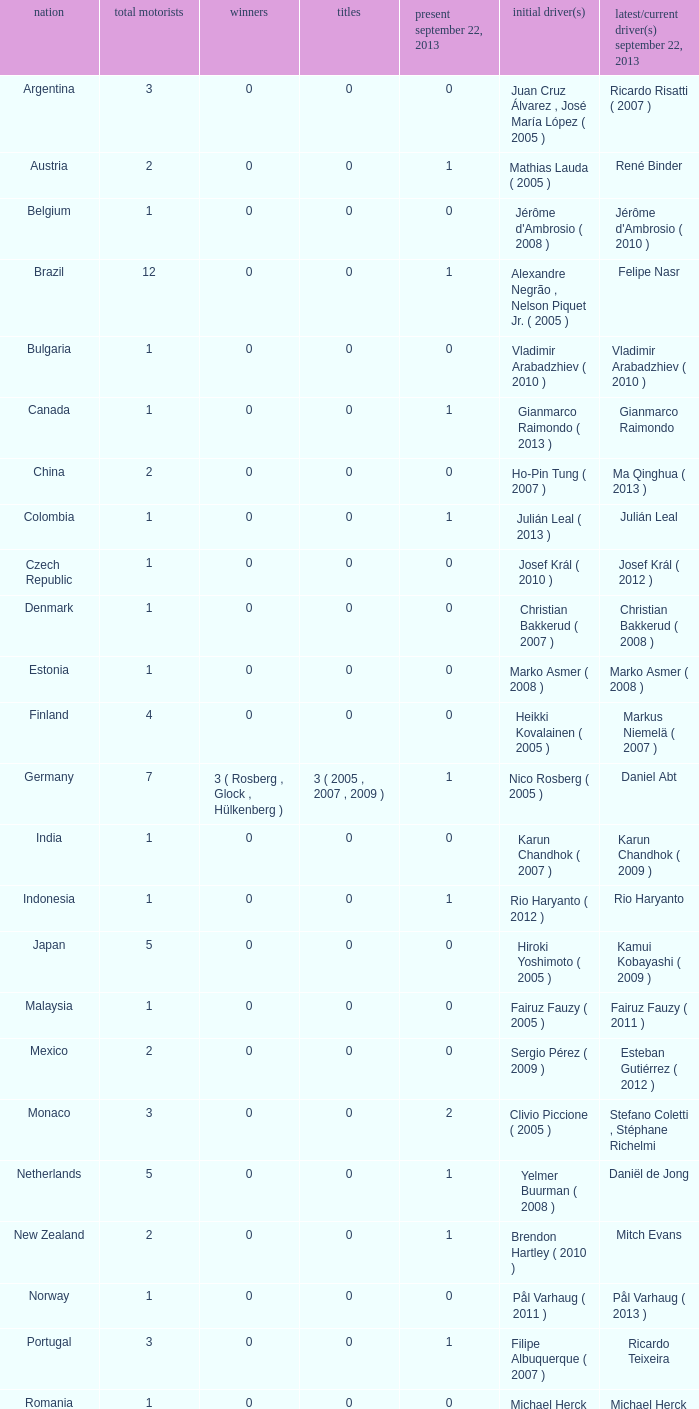How many entries are there for first driver for Canada? 1.0. 